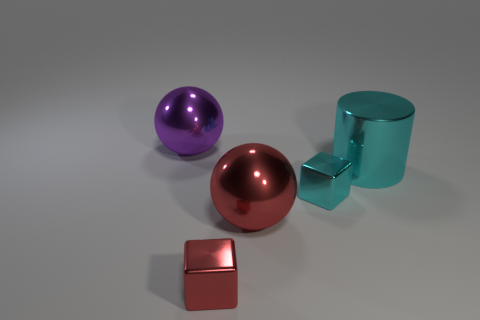Add 5 purple spheres. How many objects exist? 10 Subtract all blocks. How many objects are left? 3 Add 4 big cyan metallic objects. How many big cyan metallic objects exist? 5 Subtract 0 cyan balls. How many objects are left? 5 Subtract all red blocks. Subtract all big red things. How many objects are left? 3 Add 3 tiny red metallic blocks. How many tiny red metallic blocks are left? 4 